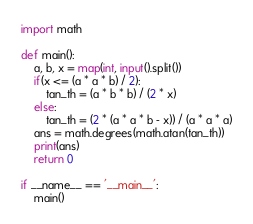<code> <loc_0><loc_0><loc_500><loc_500><_Python_>import math

def main():
    a, b, x = map(int, input().split())
    if(x <= (a * a * b) / 2): 
        tan_th = (a * b * b) / (2 * x)
    else:
        tan_th = (2 * (a * a * b - x)) / (a * a * a)
    ans = math.degrees(math.atan(tan_th))
    print(ans)
    return 0
    
if __name__ == '__main__':
    main()</code> 